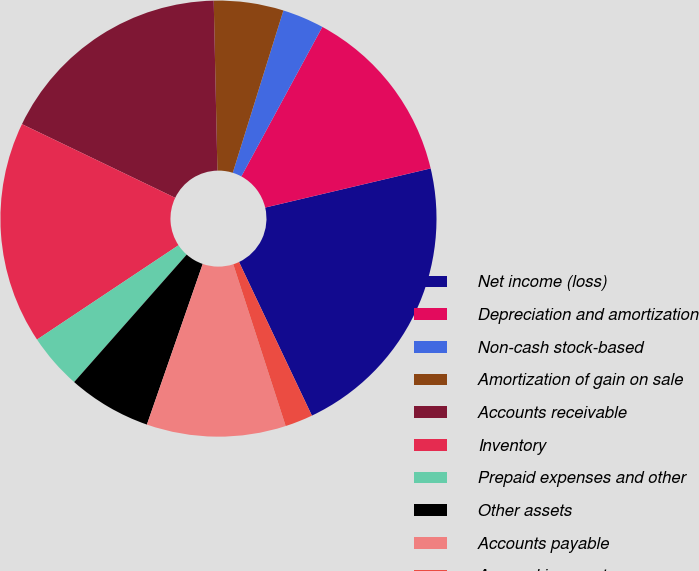Convert chart. <chart><loc_0><loc_0><loc_500><loc_500><pie_chart><fcel>Net income (loss)<fcel>Depreciation and amortization<fcel>Non-cash stock-based<fcel>Amortization of gain on sale<fcel>Accounts receivable<fcel>Inventory<fcel>Prepaid expenses and other<fcel>Other assets<fcel>Accounts payable<fcel>Accrued income taxes<nl><fcel>21.65%<fcel>13.4%<fcel>3.09%<fcel>5.16%<fcel>17.52%<fcel>16.49%<fcel>4.13%<fcel>6.19%<fcel>10.31%<fcel>2.06%<nl></chart> 